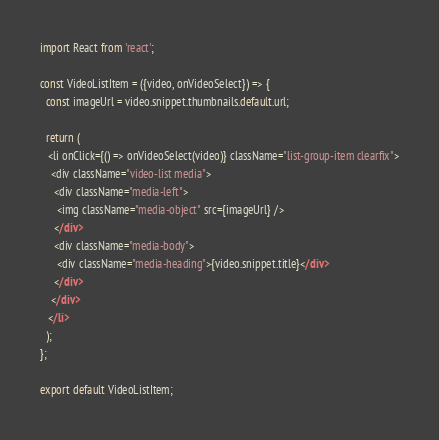Convert code to text. <code><loc_0><loc_0><loc_500><loc_500><_JavaScript_>import React from 'react';

const VideoListItem = ({video, onVideoSelect}) => {
  const imageUrl = video.snippet.thumbnails.default.url;

  return (
   <li onClick={() => onVideoSelect(video)} className="list-group-item clearfix">
    <div className="video-list media">
     <div className="media-left">
      <img className="media-object" src={imageUrl} />
     </div>
     <div className="media-body">
      <div className="media-heading">{video.snippet.title}</div>
     </div>
    </div>
   </li>
  );
};

export default VideoListItem;
</code> 